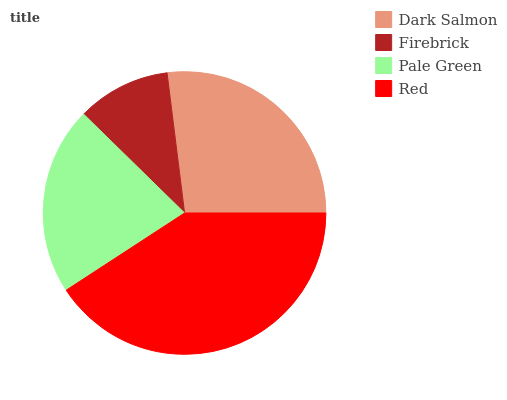Is Firebrick the minimum?
Answer yes or no. Yes. Is Red the maximum?
Answer yes or no. Yes. Is Pale Green the minimum?
Answer yes or no. No. Is Pale Green the maximum?
Answer yes or no. No. Is Pale Green greater than Firebrick?
Answer yes or no. Yes. Is Firebrick less than Pale Green?
Answer yes or no. Yes. Is Firebrick greater than Pale Green?
Answer yes or no. No. Is Pale Green less than Firebrick?
Answer yes or no. No. Is Dark Salmon the high median?
Answer yes or no. Yes. Is Pale Green the low median?
Answer yes or no. Yes. Is Red the high median?
Answer yes or no. No. Is Dark Salmon the low median?
Answer yes or no. No. 